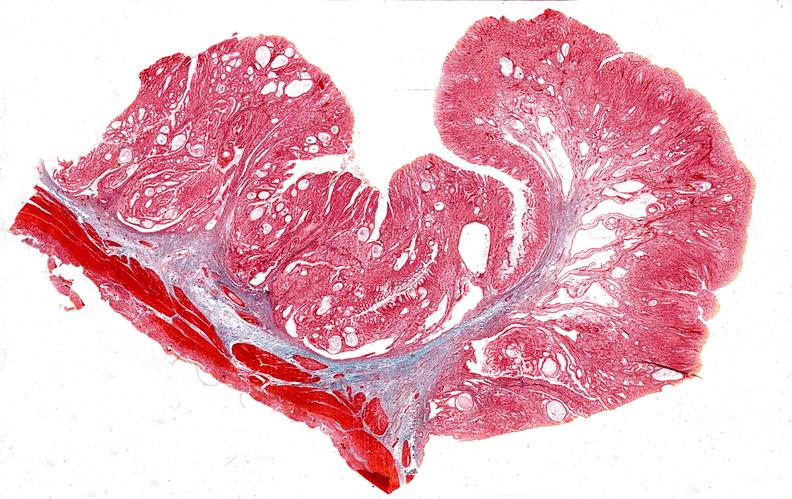s gastrointestinal present?
Answer the question using a single word or phrase. Yes 